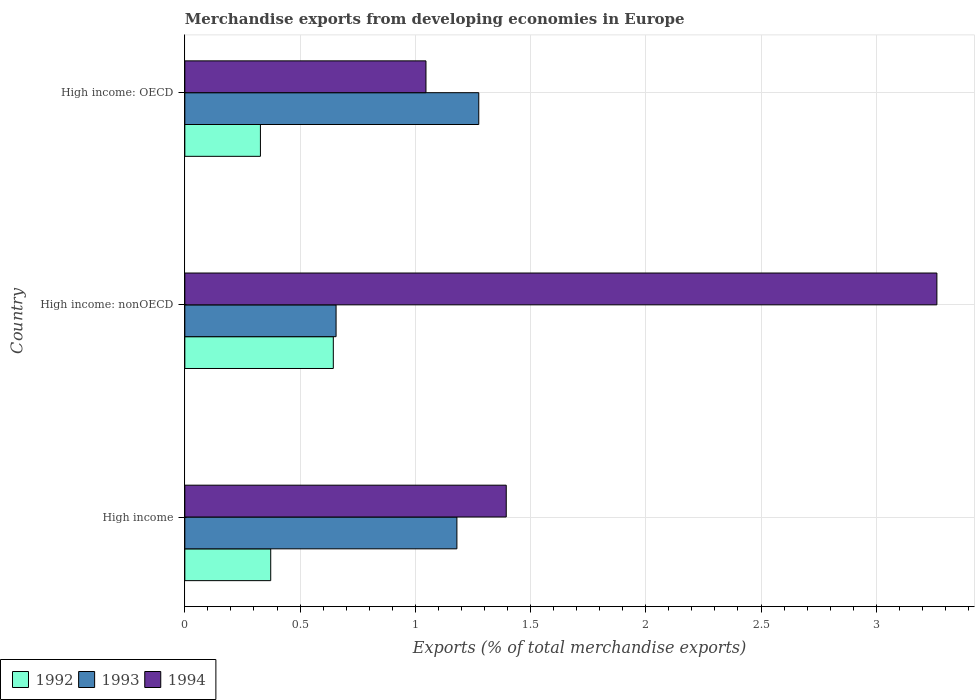How many different coloured bars are there?
Provide a succinct answer. 3. How many groups of bars are there?
Keep it short and to the point. 3. Are the number of bars per tick equal to the number of legend labels?
Give a very brief answer. Yes. Are the number of bars on each tick of the Y-axis equal?
Give a very brief answer. Yes. How many bars are there on the 3rd tick from the top?
Give a very brief answer. 3. What is the label of the 2nd group of bars from the top?
Provide a succinct answer. High income: nonOECD. What is the percentage of total merchandise exports in 1994 in High income?
Keep it short and to the point. 1.39. Across all countries, what is the maximum percentage of total merchandise exports in 1992?
Your answer should be very brief. 0.64. Across all countries, what is the minimum percentage of total merchandise exports in 1994?
Give a very brief answer. 1.05. In which country was the percentage of total merchandise exports in 1994 maximum?
Ensure brevity in your answer.  High income: nonOECD. In which country was the percentage of total merchandise exports in 1994 minimum?
Offer a terse response. High income: OECD. What is the total percentage of total merchandise exports in 1994 in the graph?
Make the answer very short. 5.7. What is the difference between the percentage of total merchandise exports in 1994 in High income and that in High income: nonOECD?
Provide a succinct answer. -1.87. What is the difference between the percentage of total merchandise exports in 1992 in High income and the percentage of total merchandise exports in 1994 in High income: nonOECD?
Your answer should be very brief. -2.89. What is the average percentage of total merchandise exports in 1994 per country?
Your response must be concise. 1.9. What is the difference between the percentage of total merchandise exports in 1994 and percentage of total merchandise exports in 1993 in High income: nonOECD?
Make the answer very short. 2.61. In how many countries, is the percentage of total merchandise exports in 1994 greater than 2.2 %?
Make the answer very short. 1. What is the ratio of the percentage of total merchandise exports in 1992 in High income to that in High income: OECD?
Keep it short and to the point. 1.14. Is the percentage of total merchandise exports in 1993 in High income less than that in High income: OECD?
Provide a short and direct response. Yes. Is the difference between the percentage of total merchandise exports in 1994 in High income and High income: nonOECD greater than the difference between the percentage of total merchandise exports in 1993 in High income and High income: nonOECD?
Offer a very short reply. No. What is the difference between the highest and the second highest percentage of total merchandise exports in 1993?
Offer a very short reply. 0.09. What is the difference between the highest and the lowest percentage of total merchandise exports in 1992?
Offer a very short reply. 0.32. In how many countries, is the percentage of total merchandise exports in 1992 greater than the average percentage of total merchandise exports in 1992 taken over all countries?
Make the answer very short. 1. Is the sum of the percentage of total merchandise exports in 1994 in High income and High income: nonOECD greater than the maximum percentage of total merchandise exports in 1992 across all countries?
Your answer should be very brief. Yes. What does the 3rd bar from the top in High income represents?
Make the answer very short. 1992. Is it the case that in every country, the sum of the percentage of total merchandise exports in 1994 and percentage of total merchandise exports in 1992 is greater than the percentage of total merchandise exports in 1993?
Provide a succinct answer. Yes. What is the difference between two consecutive major ticks on the X-axis?
Your response must be concise. 0.5. How many legend labels are there?
Your answer should be compact. 3. What is the title of the graph?
Your answer should be compact. Merchandise exports from developing economies in Europe. Does "2014" appear as one of the legend labels in the graph?
Ensure brevity in your answer.  No. What is the label or title of the X-axis?
Provide a short and direct response. Exports (% of total merchandise exports). What is the Exports (% of total merchandise exports) of 1992 in High income?
Keep it short and to the point. 0.37. What is the Exports (% of total merchandise exports) of 1993 in High income?
Ensure brevity in your answer.  1.18. What is the Exports (% of total merchandise exports) of 1994 in High income?
Offer a terse response. 1.39. What is the Exports (% of total merchandise exports) in 1992 in High income: nonOECD?
Make the answer very short. 0.64. What is the Exports (% of total merchandise exports) in 1993 in High income: nonOECD?
Make the answer very short. 0.66. What is the Exports (% of total merchandise exports) in 1994 in High income: nonOECD?
Your answer should be very brief. 3.26. What is the Exports (% of total merchandise exports) of 1992 in High income: OECD?
Provide a short and direct response. 0.33. What is the Exports (% of total merchandise exports) in 1993 in High income: OECD?
Offer a very short reply. 1.28. What is the Exports (% of total merchandise exports) of 1994 in High income: OECD?
Provide a short and direct response. 1.05. Across all countries, what is the maximum Exports (% of total merchandise exports) in 1992?
Offer a terse response. 0.64. Across all countries, what is the maximum Exports (% of total merchandise exports) of 1993?
Provide a short and direct response. 1.28. Across all countries, what is the maximum Exports (% of total merchandise exports) in 1994?
Your answer should be very brief. 3.26. Across all countries, what is the minimum Exports (% of total merchandise exports) of 1992?
Your answer should be compact. 0.33. Across all countries, what is the minimum Exports (% of total merchandise exports) of 1993?
Provide a short and direct response. 0.66. Across all countries, what is the minimum Exports (% of total merchandise exports) in 1994?
Ensure brevity in your answer.  1.05. What is the total Exports (% of total merchandise exports) in 1992 in the graph?
Keep it short and to the point. 1.34. What is the total Exports (% of total merchandise exports) of 1993 in the graph?
Provide a succinct answer. 3.11. What is the total Exports (% of total merchandise exports) of 1994 in the graph?
Ensure brevity in your answer.  5.7. What is the difference between the Exports (% of total merchandise exports) of 1992 in High income and that in High income: nonOECD?
Offer a very short reply. -0.27. What is the difference between the Exports (% of total merchandise exports) in 1993 in High income and that in High income: nonOECD?
Ensure brevity in your answer.  0.52. What is the difference between the Exports (% of total merchandise exports) in 1994 in High income and that in High income: nonOECD?
Provide a succinct answer. -1.87. What is the difference between the Exports (% of total merchandise exports) in 1992 in High income and that in High income: OECD?
Provide a short and direct response. 0.04. What is the difference between the Exports (% of total merchandise exports) in 1993 in High income and that in High income: OECD?
Ensure brevity in your answer.  -0.09. What is the difference between the Exports (% of total merchandise exports) of 1994 in High income and that in High income: OECD?
Your answer should be very brief. 0.35. What is the difference between the Exports (% of total merchandise exports) in 1992 in High income: nonOECD and that in High income: OECD?
Your response must be concise. 0.32. What is the difference between the Exports (% of total merchandise exports) in 1993 in High income: nonOECD and that in High income: OECD?
Provide a short and direct response. -0.62. What is the difference between the Exports (% of total merchandise exports) of 1994 in High income: nonOECD and that in High income: OECD?
Your answer should be compact. 2.22. What is the difference between the Exports (% of total merchandise exports) in 1992 in High income and the Exports (% of total merchandise exports) in 1993 in High income: nonOECD?
Provide a succinct answer. -0.28. What is the difference between the Exports (% of total merchandise exports) in 1992 in High income and the Exports (% of total merchandise exports) in 1994 in High income: nonOECD?
Your response must be concise. -2.89. What is the difference between the Exports (% of total merchandise exports) of 1993 in High income and the Exports (% of total merchandise exports) of 1994 in High income: nonOECD?
Provide a succinct answer. -2.08. What is the difference between the Exports (% of total merchandise exports) of 1992 in High income and the Exports (% of total merchandise exports) of 1993 in High income: OECD?
Make the answer very short. -0.9. What is the difference between the Exports (% of total merchandise exports) of 1992 in High income and the Exports (% of total merchandise exports) of 1994 in High income: OECD?
Provide a short and direct response. -0.67. What is the difference between the Exports (% of total merchandise exports) of 1993 in High income and the Exports (% of total merchandise exports) of 1994 in High income: OECD?
Ensure brevity in your answer.  0.13. What is the difference between the Exports (% of total merchandise exports) in 1992 in High income: nonOECD and the Exports (% of total merchandise exports) in 1993 in High income: OECD?
Your response must be concise. -0.63. What is the difference between the Exports (% of total merchandise exports) in 1992 in High income: nonOECD and the Exports (% of total merchandise exports) in 1994 in High income: OECD?
Provide a short and direct response. -0.4. What is the difference between the Exports (% of total merchandise exports) of 1993 in High income: nonOECD and the Exports (% of total merchandise exports) of 1994 in High income: OECD?
Give a very brief answer. -0.39. What is the average Exports (% of total merchandise exports) in 1992 per country?
Give a very brief answer. 0.45. What is the average Exports (% of total merchandise exports) of 1993 per country?
Keep it short and to the point. 1.04. What is the average Exports (% of total merchandise exports) of 1994 per country?
Ensure brevity in your answer.  1.9. What is the difference between the Exports (% of total merchandise exports) of 1992 and Exports (% of total merchandise exports) of 1993 in High income?
Make the answer very short. -0.81. What is the difference between the Exports (% of total merchandise exports) of 1992 and Exports (% of total merchandise exports) of 1994 in High income?
Offer a terse response. -1.02. What is the difference between the Exports (% of total merchandise exports) of 1993 and Exports (% of total merchandise exports) of 1994 in High income?
Ensure brevity in your answer.  -0.21. What is the difference between the Exports (% of total merchandise exports) of 1992 and Exports (% of total merchandise exports) of 1993 in High income: nonOECD?
Your answer should be very brief. -0.01. What is the difference between the Exports (% of total merchandise exports) of 1992 and Exports (% of total merchandise exports) of 1994 in High income: nonOECD?
Ensure brevity in your answer.  -2.62. What is the difference between the Exports (% of total merchandise exports) in 1993 and Exports (% of total merchandise exports) in 1994 in High income: nonOECD?
Give a very brief answer. -2.61. What is the difference between the Exports (% of total merchandise exports) of 1992 and Exports (% of total merchandise exports) of 1993 in High income: OECD?
Keep it short and to the point. -0.95. What is the difference between the Exports (% of total merchandise exports) in 1992 and Exports (% of total merchandise exports) in 1994 in High income: OECD?
Your answer should be compact. -0.72. What is the difference between the Exports (% of total merchandise exports) of 1993 and Exports (% of total merchandise exports) of 1994 in High income: OECD?
Your answer should be very brief. 0.23. What is the ratio of the Exports (% of total merchandise exports) in 1992 in High income to that in High income: nonOECD?
Your response must be concise. 0.58. What is the ratio of the Exports (% of total merchandise exports) in 1993 in High income to that in High income: nonOECD?
Give a very brief answer. 1.8. What is the ratio of the Exports (% of total merchandise exports) of 1994 in High income to that in High income: nonOECD?
Keep it short and to the point. 0.43. What is the ratio of the Exports (% of total merchandise exports) of 1992 in High income to that in High income: OECD?
Ensure brevity in your answer.  1.14. What is the ratio of the Exports (% of total merchandise exports) of 1993 in High income to that in High income: OECD?
Ensure brevity in your answer.  0.93. What is the ratio of the Exports (% of total merchandise exports) of 1994 in High income to that in High income: OECD?
Provide a short and direct response. 1.33. What is the ratio of the Exports (% of total merchandise exports) in 1992 in High income: nonOECD to that in High income: OECD?
Offer a very short reply. 1.96. What is the ratio of the Exports (% of total merchandise exports) of 1993 in High income: nonOECD to that in High income: OECD?
Make the answer very short. 0.51. What is the ratio of the Exports (% of total merchandise exports) in 1994 in High income: nonOECD to that in High income: OECD?
Keep it short and to the point. 3.12. What is the difference between the highest and the second highest Exports (% of total merchandise exports) of 1992?
Give a very brief answer. 0.27. What is the difference between the highest and the second highest Exports (% of total merchandise exports) of 1993?
Ensure brevity in your answer.  0.09. What is the difference between the highest and the second highest Exports (% of total merchandise exports) in 1994?
Provide a succinct answer. 1.87. What is the difference between the highest and the lowest Exports (% of total merchandise exports) in 1992?
Your answer should be very brief. 0.32. What is the difference between the highest and the lowest Exports (% of total merchandise exports) of 1993?
Ensure brevity in your answer.  0.62. What is the difference between the highest and the lowest Exports (% of total merchandise exports) in 1994?
Give a very brief answer. 2.22. 